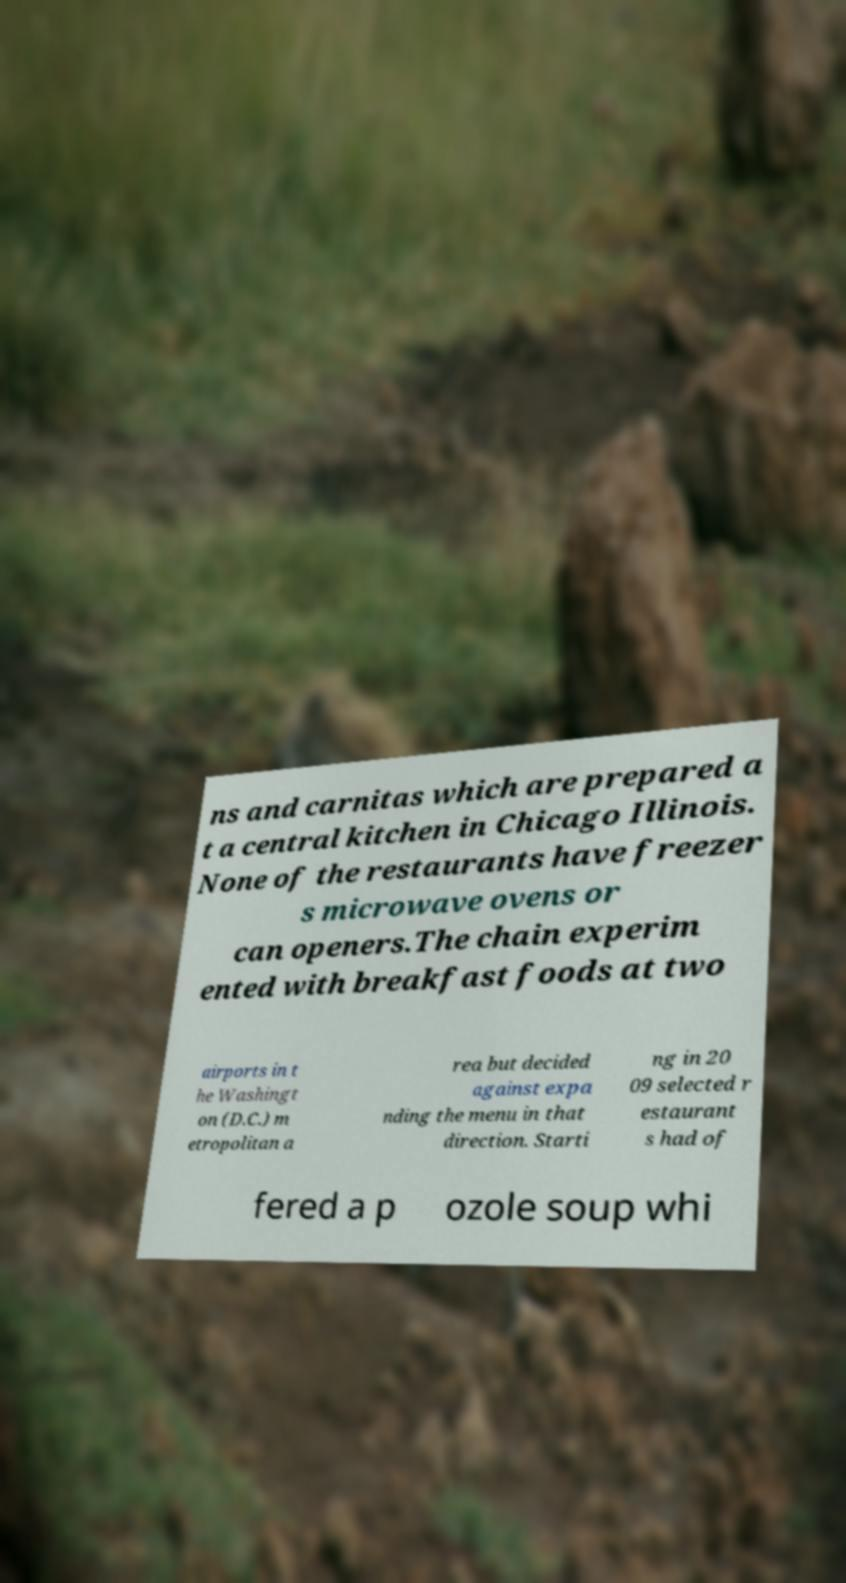There's text embedded in this image that I need extracted. Can you transcribe it verbatim? ns and carnitas which are prepared a t a central kitchen in Chicago Illinois. None of the restaurants have freezer s microwave ovens or can openers.The chain experim ented with breakfast foods at two airports in t he Washingt on (D.C.) m etropolitan a rea but decided against expa nding the menu in that direction. Starti ng in 20 09 selected r estaurant s had of fered a p ozole soup whi 